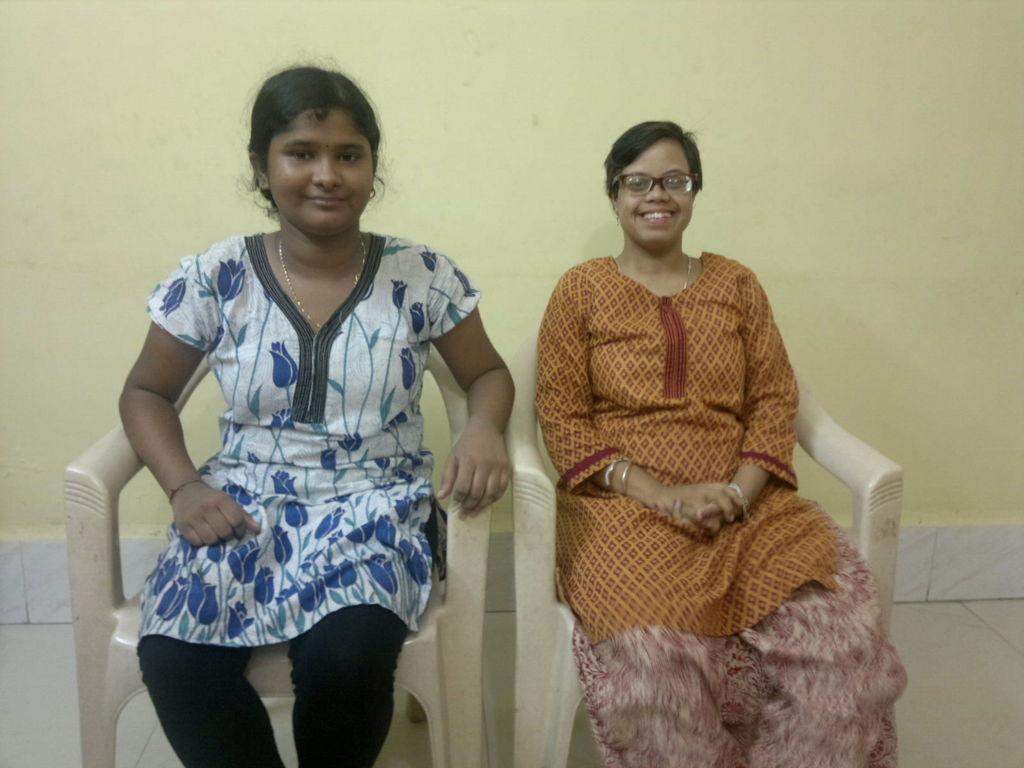Could you give a brief overview of what you see in this image? In this picture I can see two people sitting on the chair. I can see the wall in the background. 